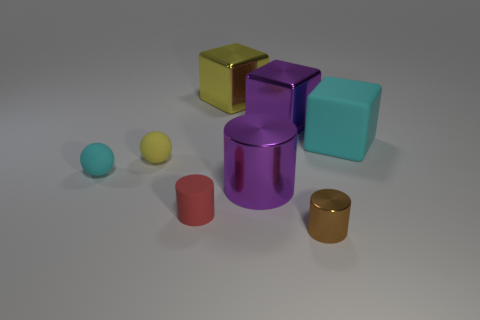What is the size of the matte thing that is both in front of the yellow ball and behind the red rubber cylinder?
Provide a succinct answer. Small. What color is the metal object that is both in front of the big purple metal cube and behind the small red object?
Ensure brevity in your answer.  Purple. Is the number of big yellow blocks to the left of the yellow block less than the number of small red matte cylinders behind the purple metal block?
Your answer should be very brief. No. Is there anything else of the same color as the rubber cube?
Your response must be concise. Yes. What is the shape of the small brown shiny object?
Keep it short and to the point. Cylinder. There is another tiny cylinder that is the same material as the purple cylinder; what color is it?
Offer a very short reply. Brown. Are there more brown metallic blocks than small cyan spheres?
Make the answer very short. No. Is there a small shiny object?
Keep it short and to the point. Yes. There is a rubber object that is right of the purple metallic thing in front of the big purple shiny block; what shape is it?
Make the answer very short. Cube. What number of things are large cyan matte cubes or balls that are to the left of the yellow rubber ball?
Give a very brief answer. 2. 